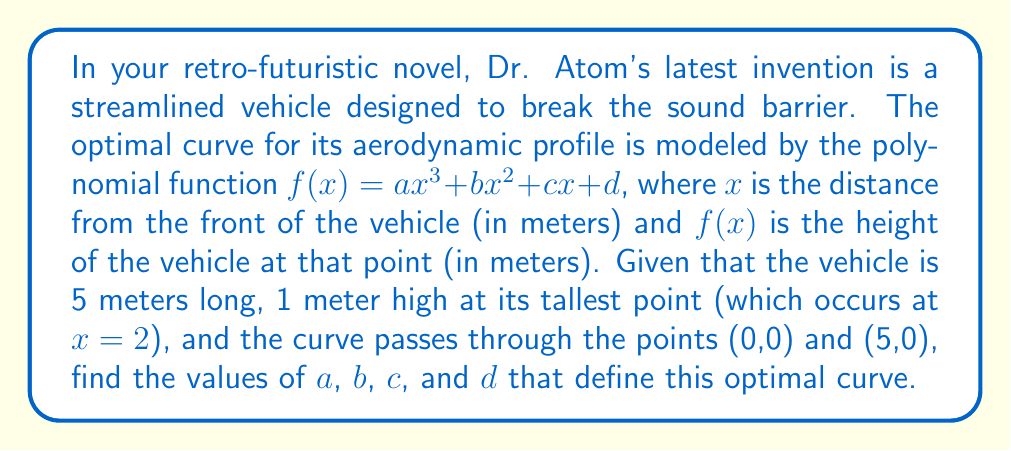Teach me how to tackle this problem. Let's approach this step-by-step:

1) We know that $f(x) = ax^3 + bx^2 + cx + d$

2) The curve passes through (0,0), so:
   $f(0) = a(0)^3 + b(0)^2 + c(0) + d = 0$
   Therefore, $d = 0$

3) The curve passes through (5,0), so:
   $f(5) = a(5)^3 + b(5)^2 + 5c + 0 = 0$
   $125a + 25b + 5c = 0$ ... (Equation 1)

4) The highest point is at $x=2$ and $f(2)=1$:
   $f(2) = a(2)^3 + b(2)^2 + 2c + 0 = 1$
   $8a + 4b + 2c = 1$ ... (Equation 2)

5) At the highest point, the derivative $f'(x)$ must be zero:
   $f'(x) = 3ax^2 + 2bx + c$
   $f'(2) = 3a(2)^2 + 2b(2) + c = 0$
   $12a + 4b + c = 0$ ... (Equation 3)

6) Now we have a system of three equations:
   125a + 25b + 5c = 0  (Eq. 1)
   8a + 4b + 2c = 1     (Eq. 2)
   12a + 4b + c = 0     (Eq. 3)

7) Subtracting Eq. 3 from Eq. 1:
   113a + 21b + 4c = 0  (Eq. 4)

8) Multiplying Eq. 2 by 2 and subtracting Eq. 3:
   4a + 4b + 3c = 2     (Eq. 5)

9) From Eq. 3: $c = -12a - 4b$
   Substituting this into Eq. 5:
   4a + 4b + 3(-12a - 4b) = 2
   4a + 4b - 36a - 12b = 2
   -32a - 8b = 2
   4a + b = -1/4        (Eq. 6)

10) Substituting $c = -12a - 4b$ into Eq. 4:
    113a + 21b + 4(-12a - 4b) = 0
    113a + 21b - 48a - 16b = 0
    65a + 5b = 0
    13a + b = 0         (Eq. 7)

11) Subtracting Eq. 6 from Eq. 7:
    9a = 1/4
    a = 1/36

12) Substituting this back into Eq. 6:
    4(1/36) + b = -1/4
    1/9 + b = -1/4
    b = -1/4 - 1/9 = -13/36

13) We can now find c using Eq. 3:
    12(1/36) + 4(-13/36) + c = 0
    1/3 - 13/9 + c = 0
    c = 13/9 - 1/3 = 10/27

Therefore, $a = 1/36$, $b = -13/36$, $c = 10/27$, and $d = 0$.
Answer: $a = \frac{1}{36}$, $b = -\frac{13}{36}$, $c = \frac{10}{27}$, $d = 0$ 